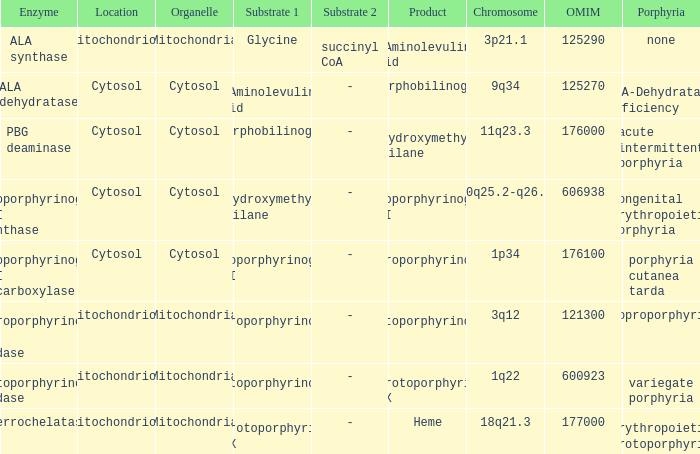What is the location of the enzyme Uroporphyrinogen iii Synthase? Cytosol. 